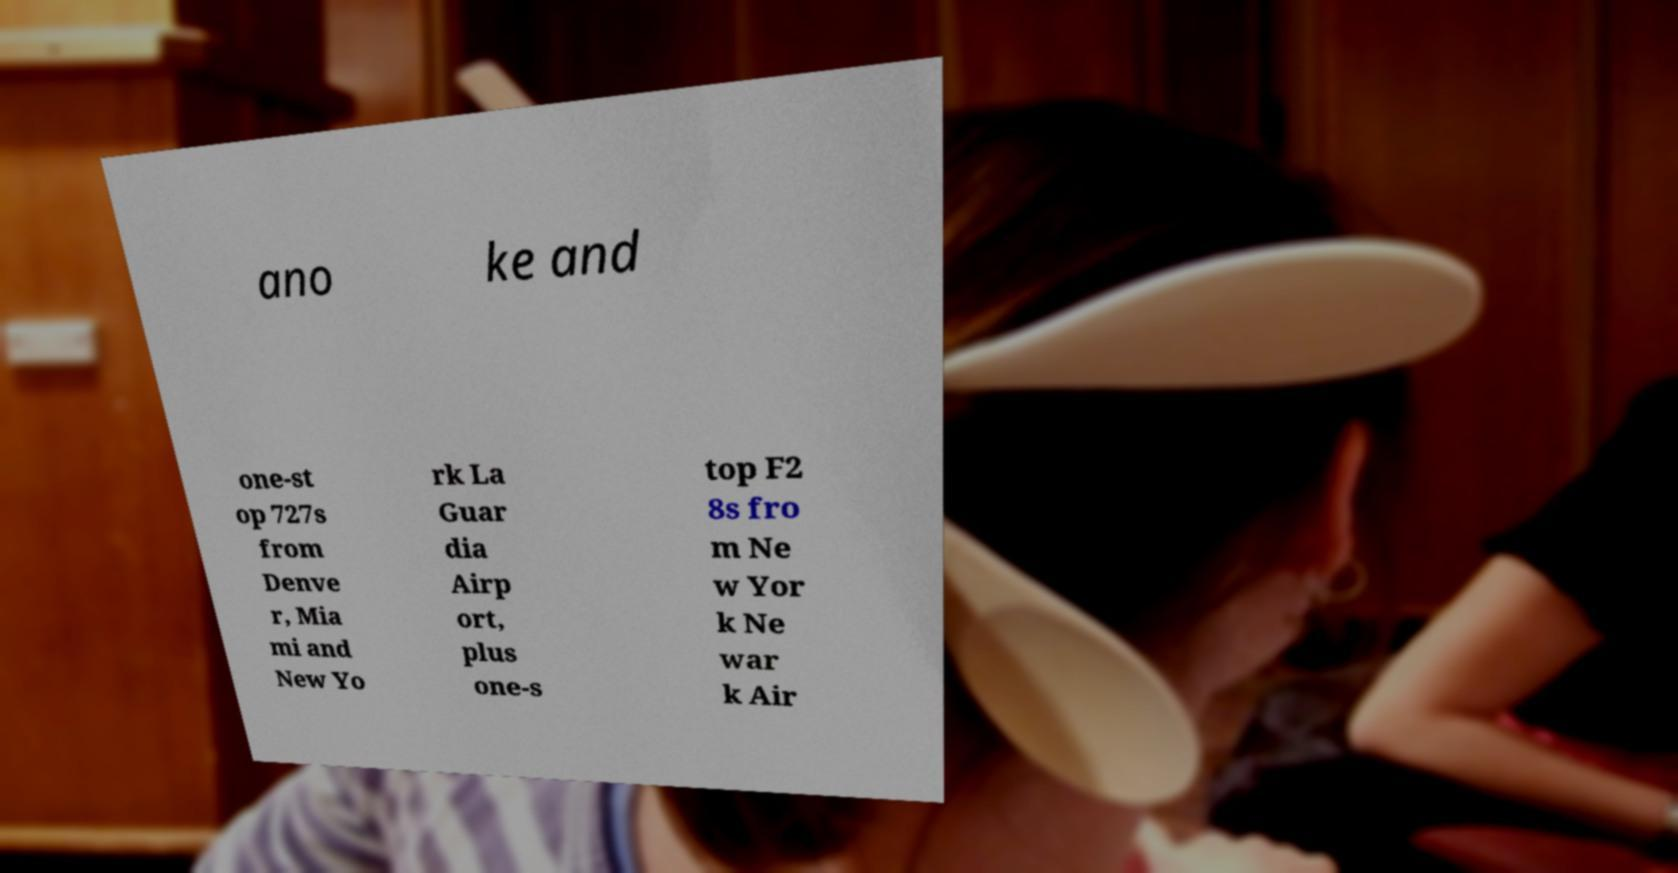Please read and relay the text visible in this image. What does it say? ano ke and one-st op 727s from Denve r, Mia mi and New Yo rk La Guar dia Airp ort, plus one-s top F2 8s fro m Ne w Yor k Ne war k Air 